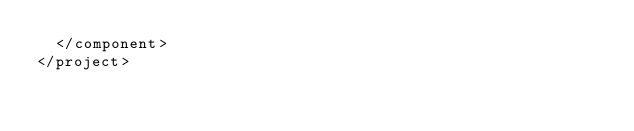Convert code to text. <code><loc_0><loc_0><loc_500><loc_500><_XML_>  </component>
</project>
</code> 